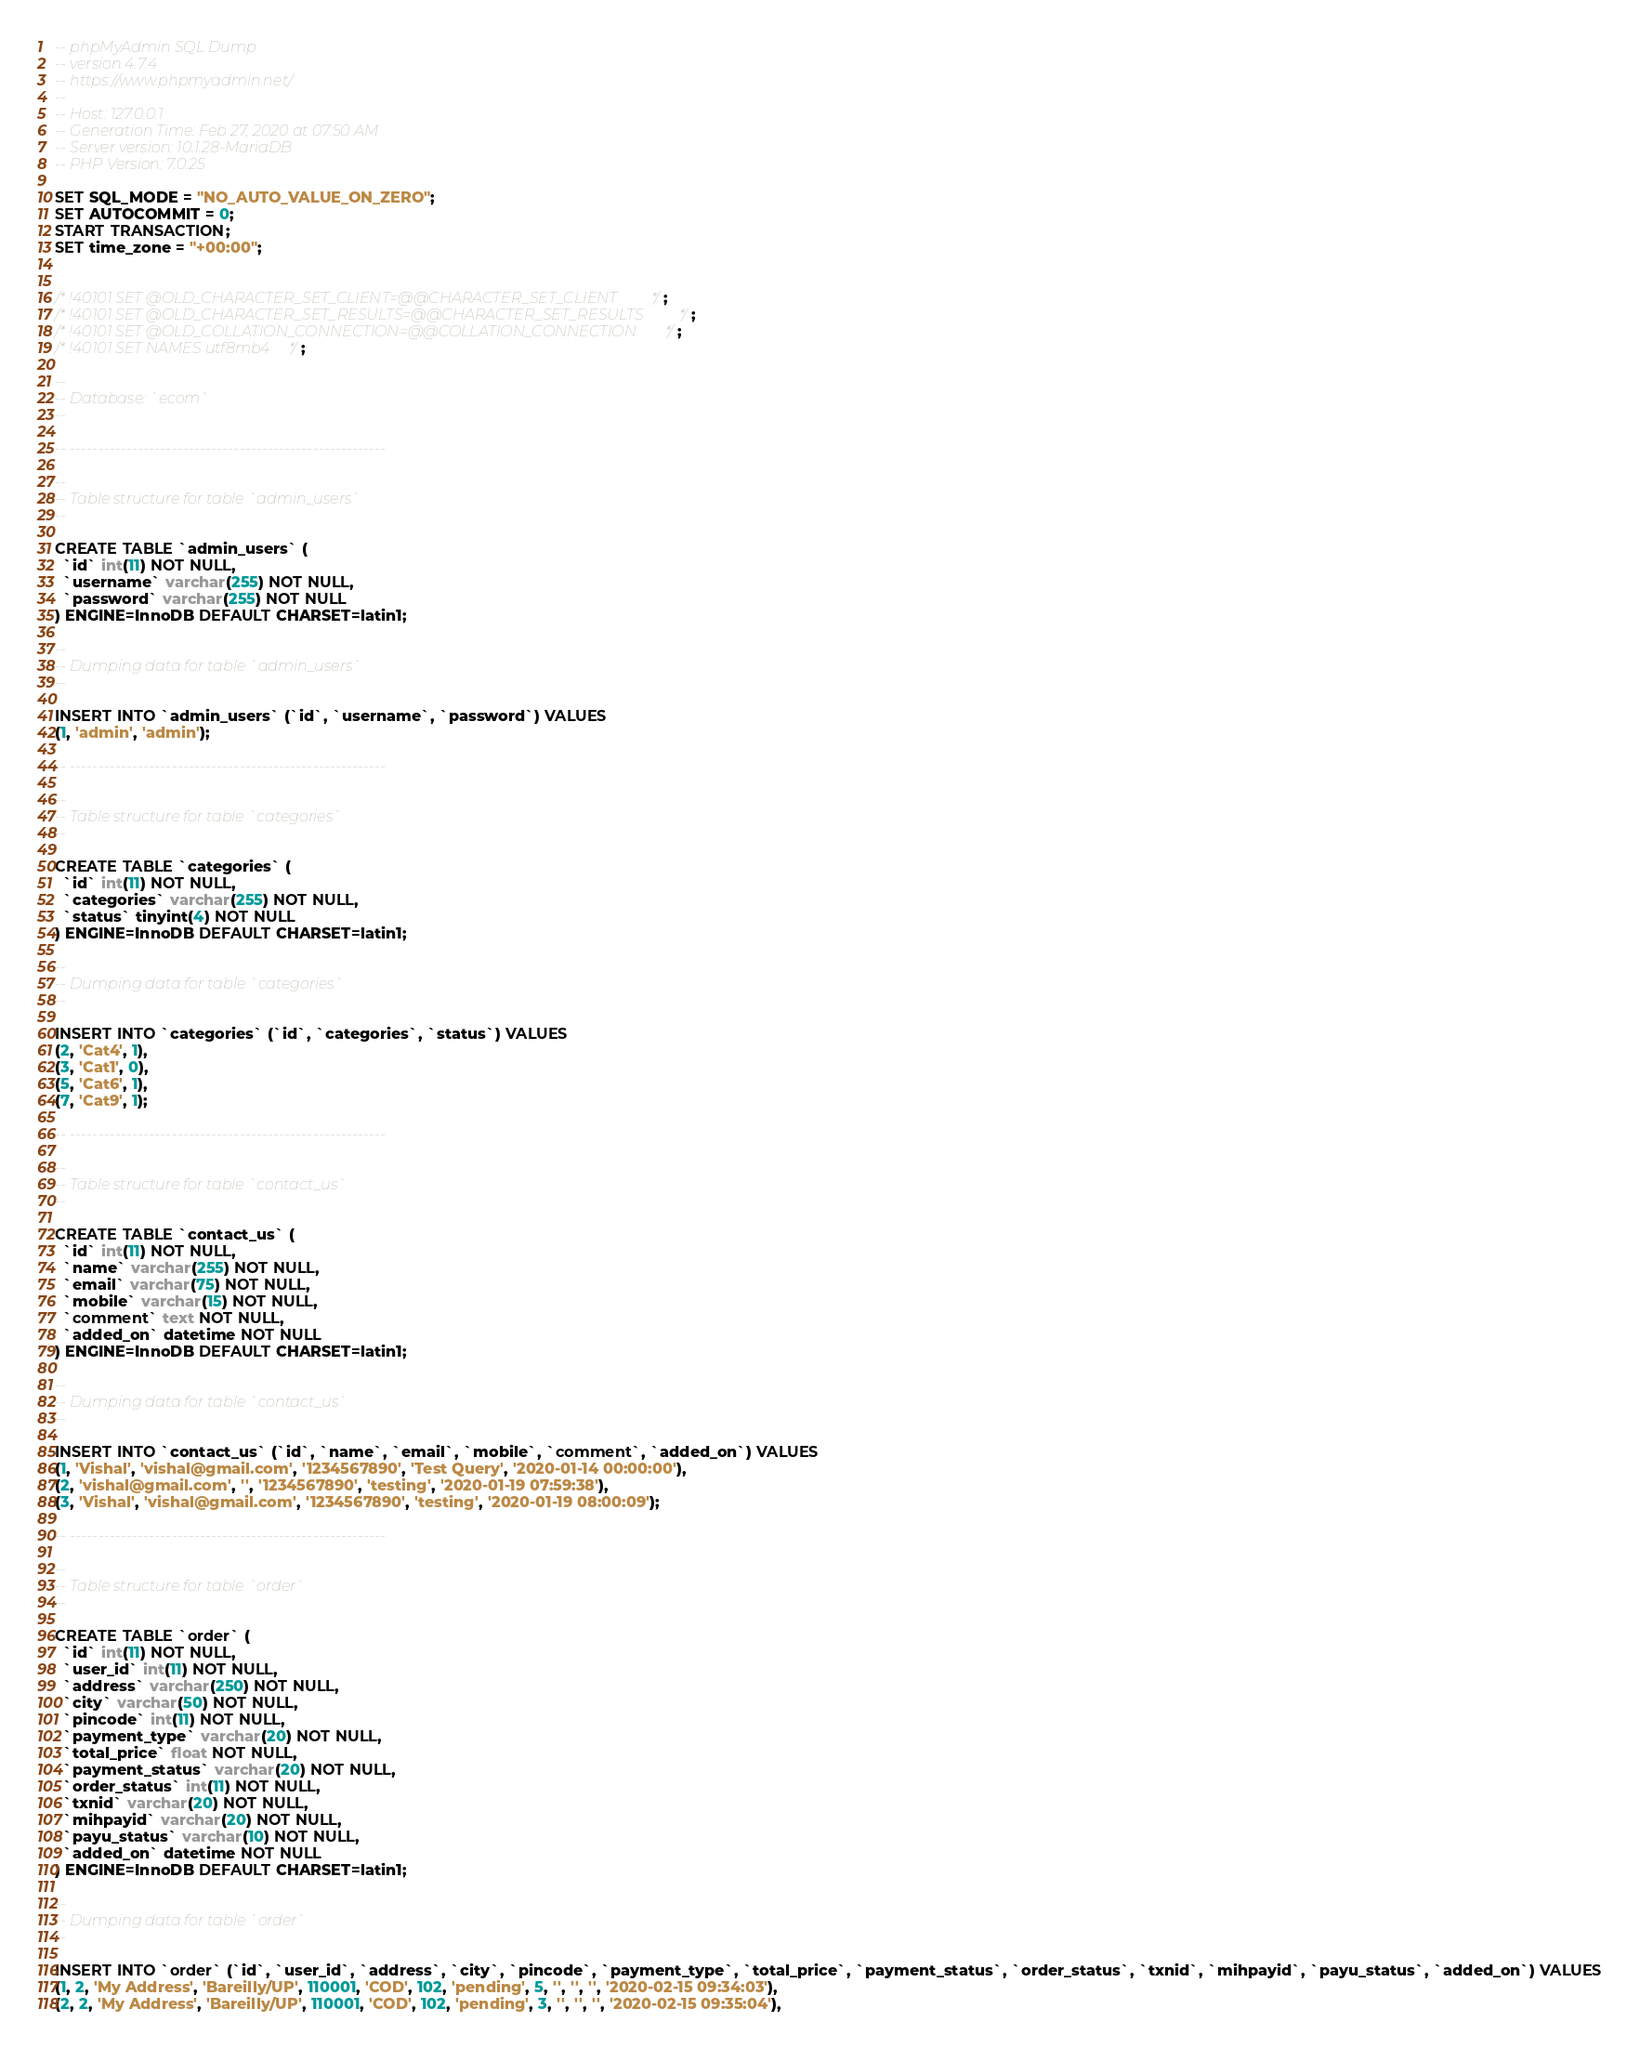<code> <loc_0><loc_0><loc_500><loc_500><_SQL_>-- phpMyAdmin SQL Dump
-- version 4.7.4
-- https://www.phpmyadmin.net/
--
-- Host: 127.0.0.1
-- Generation Time: Feb 27, 2020 at 07:50 AM
-- Server version: 10.1.28-MariaDB
-- PHP Version: 7.0.25

SET SQL_MODE = "NO_AUTO_VALUE_ON_ZERO";
SET AUTOCOMMIT = 0;
START TRANSACTION;
SET time_zone = "+00:00";


/*!40101 SET @OLD_CHARACTER_SET_CLIENT=@@CHARACTER_SET_CLIENT */;
/*!40101 SET @OLD_CHARACTER_SET_RESULTS=@@CHARACTER_SET_RESULTS */;
/*!40101 SET @OLD_COLLATION_CONNECTION=@@COLLATION_CONNECTION */;
/*!40101 SET NAMES utf8mb4 */;

--
-- Database: `ecom`
--

-- --------------------------------------------------------

--
-- Table structure for table `admin_users`
--

CREATE TABLE `admin_users` (
  `id` int(11) NOT NULL,
  `username` varchar(255) NOT NULL,
  `password` varchar(255) NOT NULL
) ENGINE=InnoDB DEFAULT CHARSET=latin1;

--
-- Dumping data for table `admin_users`
--

INSERT INTO `admin_users` (`id`, `username`, `password`) VALUES
(1, 'admin', 'admin');

-- --------------------------------------------------------

--
-- Table structure for table `categories`
--

CREATE TABLE `categories` (
  `id` int(11) NOT NULL,
  `categories` varchar(255) NOT NULL,
  `status` tinyint(4) NOT NULL
) ENGINE=InnoDB DEFAULT CHARSET=latin1;

--
-- Dumping data for table `categories`
--

INSERT INTO `categories` (`id`, `categories`, `status`) VALUES
(2, 'Cat4', 1),
(3, 'Cat1', 0),
(5, 'Cat6', 1),
(7, 'Cat9', 1);

-- --------------------------------------------------------

--
-- Table structure for table `contact_us`
--

CREATE TABLE `contact_us` (
  `id` int(11) NOT NULL,
  `name` varchar(255) NOT NULL,
  `email` varchar(75) NOT NULL,
  `mobile` varchar(15) NOT NULL,
  `comment` text NOT NULL,
  `added_on` datetime NOT NULL
) ENGINE=InnoDB DEFAULT CHARSET=latin1;

--
-- Dumping data for table `contact_us`
--

INSERT INTO `contact_us` (`id`, `name`, `email`, `mobile`, `comment`, `added_on`) VALUES
(1, 'Vishal', 'vishal@gmail.com', '1234567890', 'Test Query', '2020-01-14 00:00:00'),
(2, 'vishal@gmail.com', '', '1234567890', 'testing', '2020-01-19 07:59:38'),
(3, 'Vishal', 'vishal@gmail.com', '1234567890', 'testing', '2020-01-19 08:00:09');

-- --------------------------------------------------------

--
-- Table structure for table `order`
--

CREATE TABLE `order` (
  `id` int(11) NOT NULL,
  `user_id` int(11) NOT NULL,
  `address` varchar(250) NOT NULL,
  `city` varchar(50) NOT NULL,
  `pincode` int(11) NOT NULL,
  `payment_type` varchar(20) NOT NULL,
  `total_price` float NOT NULL,
  `payment_status` varchar(20) NOT NULL,
  `order_status` int(11) NOT NULL,
  `txnid` varchar(20) NOT NULL,
  `mihpayid` varchar(20) NOT NULL,
  `payu_status` varchar(10) NOT NULL,
  `added_on` datetime NOT NULL
) ENGINE=InnoDB DEFAULT CHARSET=latin1;

--
-- Dumping data for table `order`
--

INSERT INTO `order` (`id`, `user_id`, `address`, `city`, `pincode`, `payment_type`, `total_price`, `payment_status`, `order_status`, `txnid`, `mihpayid`, `payu_status`, `added_on`) VALUES
(1, 2, 'My Address', 'Bareilly/UP', 110001, 'COD', 102, 'pending', 5, '', '', '', '2020-02-15 09:34:03'),
(2, 2, 'My Address', 'Bareilly/UP', 110001, 'COD', 102, 'pending', 3, '', '', '', '2020-02-15 09:35:04'),</code> 